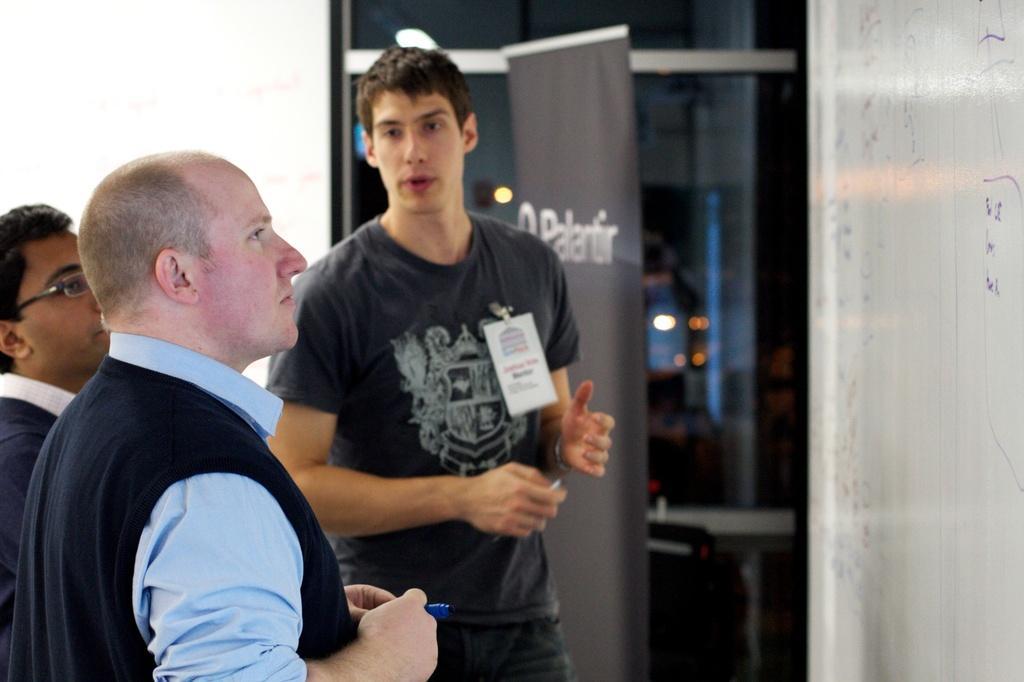Could you give a brief overview of what you see in this image? In this image we can see there are three people standing and talking to each other, in front of them there is a board. In the background there is a banner, glass window and wall. 